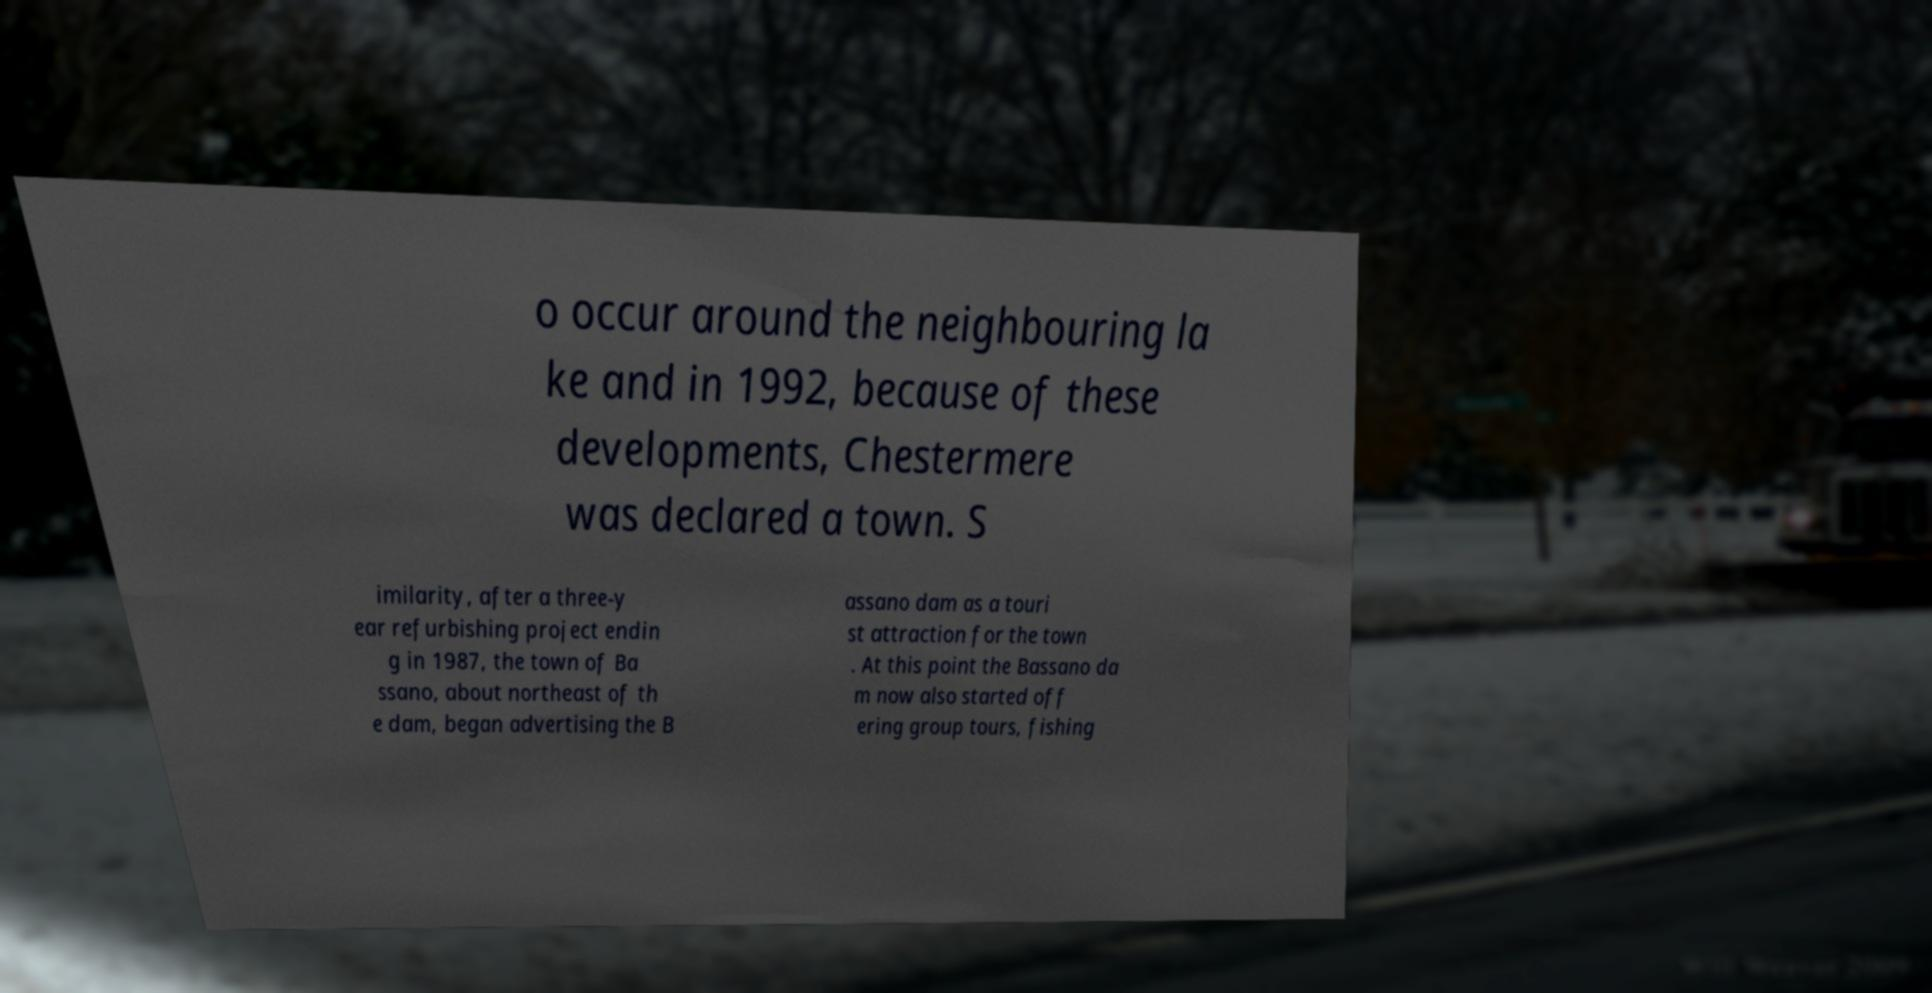Can you accurately transcribe the text from the provided image for me? o occur around the neighbouring la ke and in 1992, because of these developments, Chestermere was declared a town. S imilarity, after a three-y ear refurbishing project endin g in 1987, the town of Ba ssano, about northeast of th e dam, began advertising the B assano dam as a touri st attraction for the town . At this point the Bassano da m now also started off ering group tours, fishing 